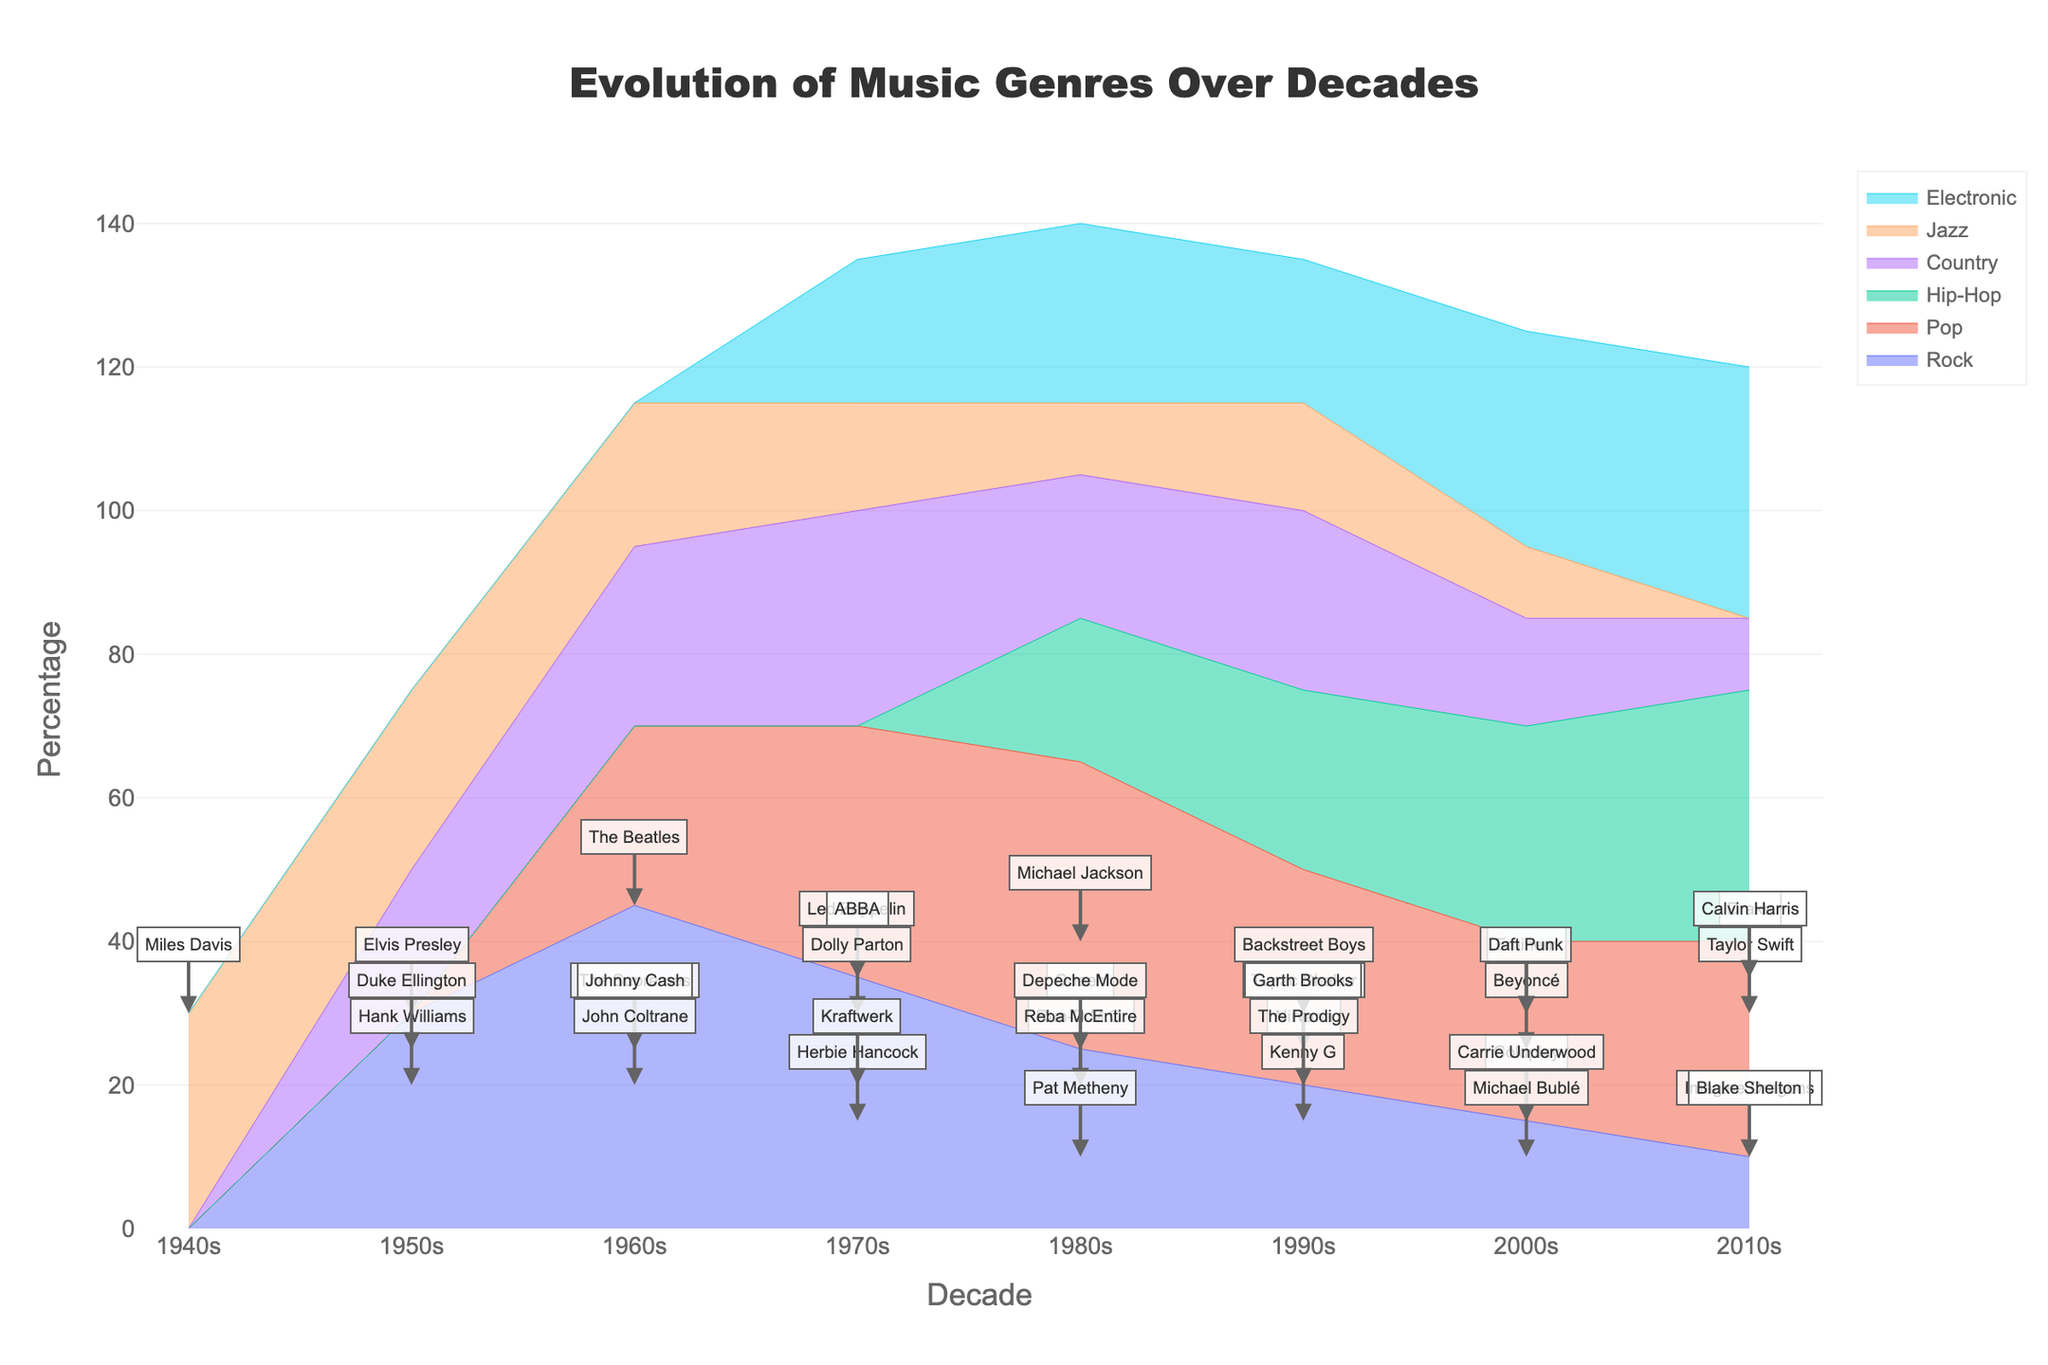What genre dominates the music scene in the 1980s? By examining the height of the stream graph in the 1980s, we see that Pop has the highest percentage, around 40%.
Answer: Pop Which genre has the most prominent artist in the 1950s? In the 1950s, Rock has the highest percentage (30%), with Elvis Presley as the notable artist.
Answer: Rock How do the percentages of Rock and Country compare in the 1970s? In the 1970s, Rock has a percentage of 35%, while Country has a percentage of 30%. Therefore, Rock's percentage is slightly higher than Country's.
Answer: Rock is higher Which genre shows a consistent decrease in percentage from the 1950s to the 2010s? Rock shows a consistent decrease over the decades, starting at 30% in the 1950s and declining to 10% by the 2010s.
Answer: Rock What is the sum of the percentages of Pop and Hip-Hop in the 2000s? Pop in the 2000s has a percentage of 25%, and Hip-Hop has 30%. Their sum is 25% + 30% = 55%.
Answer: 55% Who are the notable artists highlighted in the 1990s for the genres Pop and Hip-Hop? In the 1990s, the notable artist for Pop is Backstreet Boys with 30%, and for Hip-Hop, it's Tupac Shakur with 25%.
Answer: Backstreet Boys and Tupac Shakur Which genre has the smallest percentage in the 2000s? Jazz has the smallest percentage in the 2000s, with a value of 10%.
Answer: Jazz What trend can be observed in the Electronic genre over the decades? The percentage for the Electronic genre increases steadily over the decades from 20% in the 1970s to 35% in the 2010s.
Answer: Increasing trend Which genre had the least presence in the 1940s, and who was the notable artist? Jazz was the only genre in the 1940s with a presence, represented by Miles Davis at 30%. Since there were no other genres listed for that decade, Jazz had the least presence by default.
Answer: Jazz, Miles Davis 